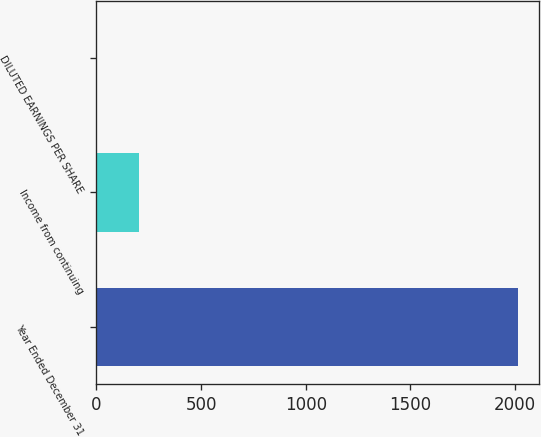Convert chart to OTSL. <chart><loc_0><loc_0><loc_500><loc_500><bar_chart><fcel>Year Ended December 31<fcel>Income from continuing<fcel>DILUTED EARNINGS PER SHARE<nl><fcel>2015<fcel>201.9<fcel>0.44<nl></chart> 